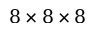<formula> <loc_0><loc_0><loc_500><loc_500>8 \times 8 \times 8</formula> 